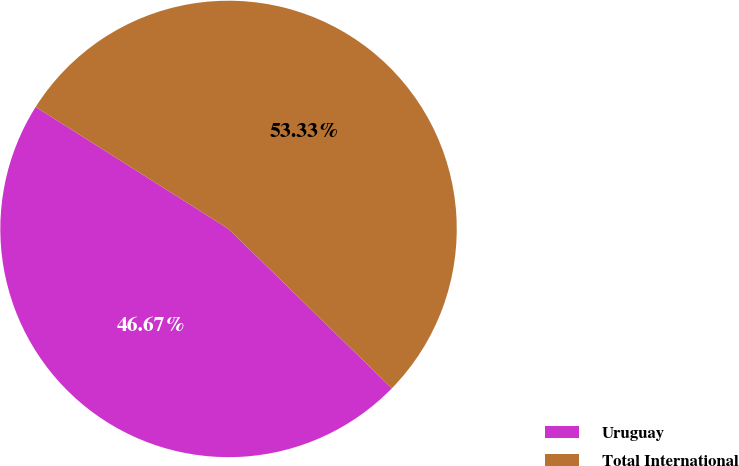<chart> <loc_0><loc_0><loc_500><loc_500><pie_chart><fcel>Uruguay<fcel>Total International<nl><fcel>46.67%<fcel>53.33%<nl></chart> 